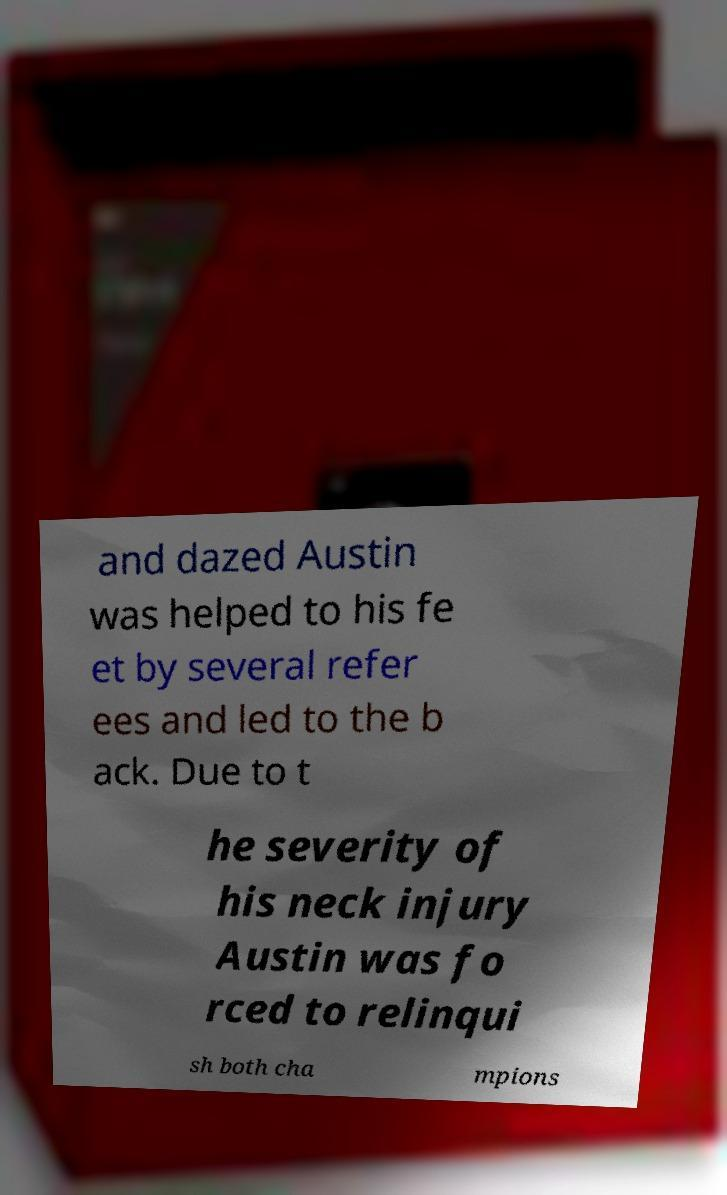Could you extract and type out the text from this image? and dazed Austin was helped to his fe et by several refer ees and led to the b ack. Due to t he severity of his neck injury Austin was fo rced to relinqui sh both cha mpions 